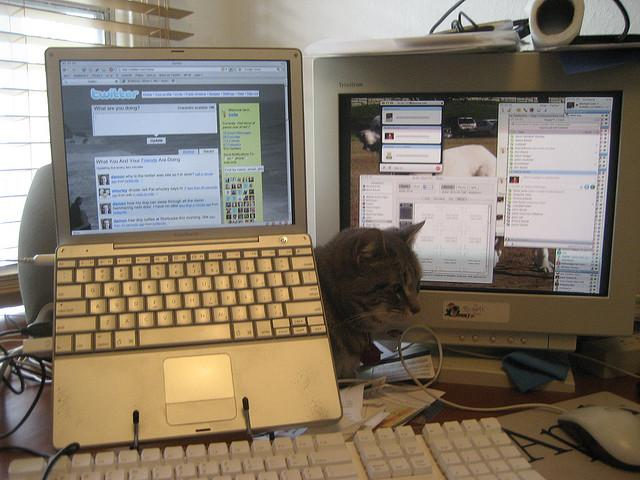What is the cat hiding behind?

Choices:
A) owners body
B) laptop
C) box
D) couch laptop 